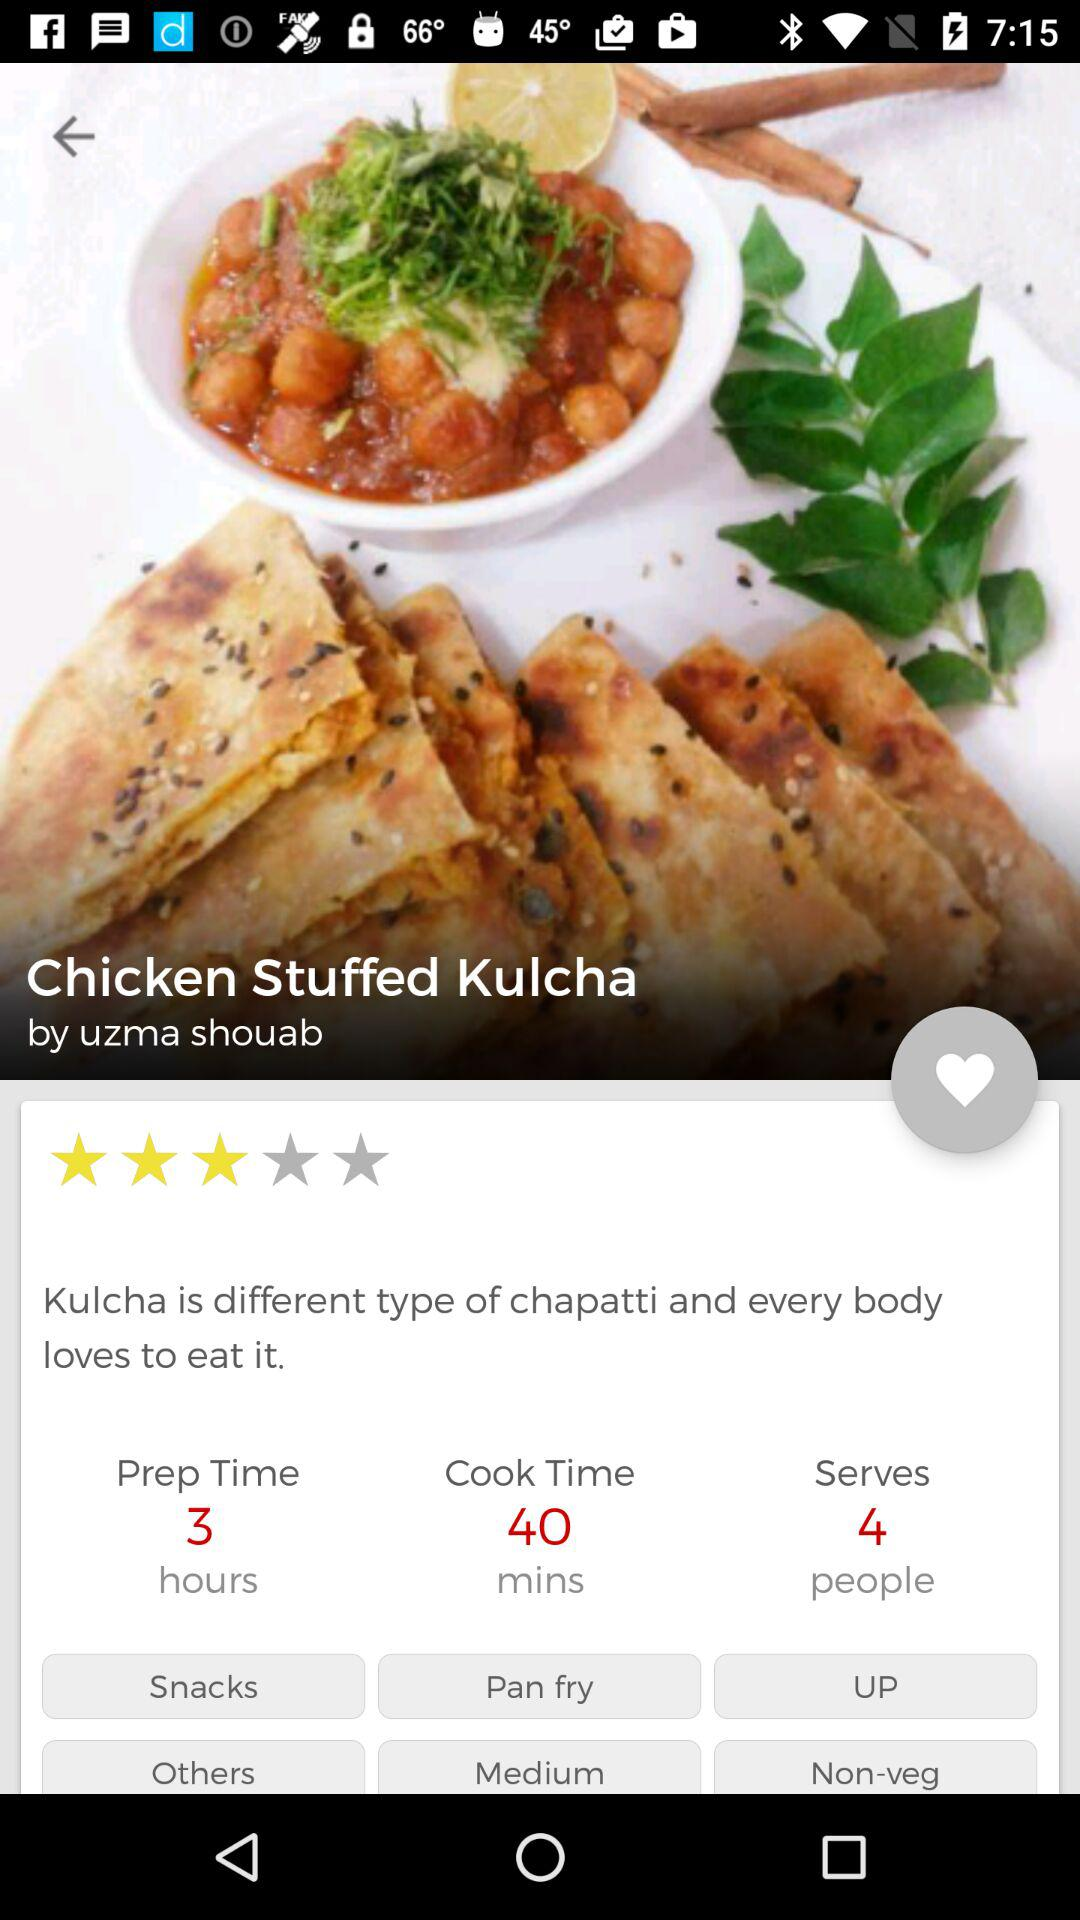What is the cooking time for the dish? The cooking time for the dish is 40 minutes. 